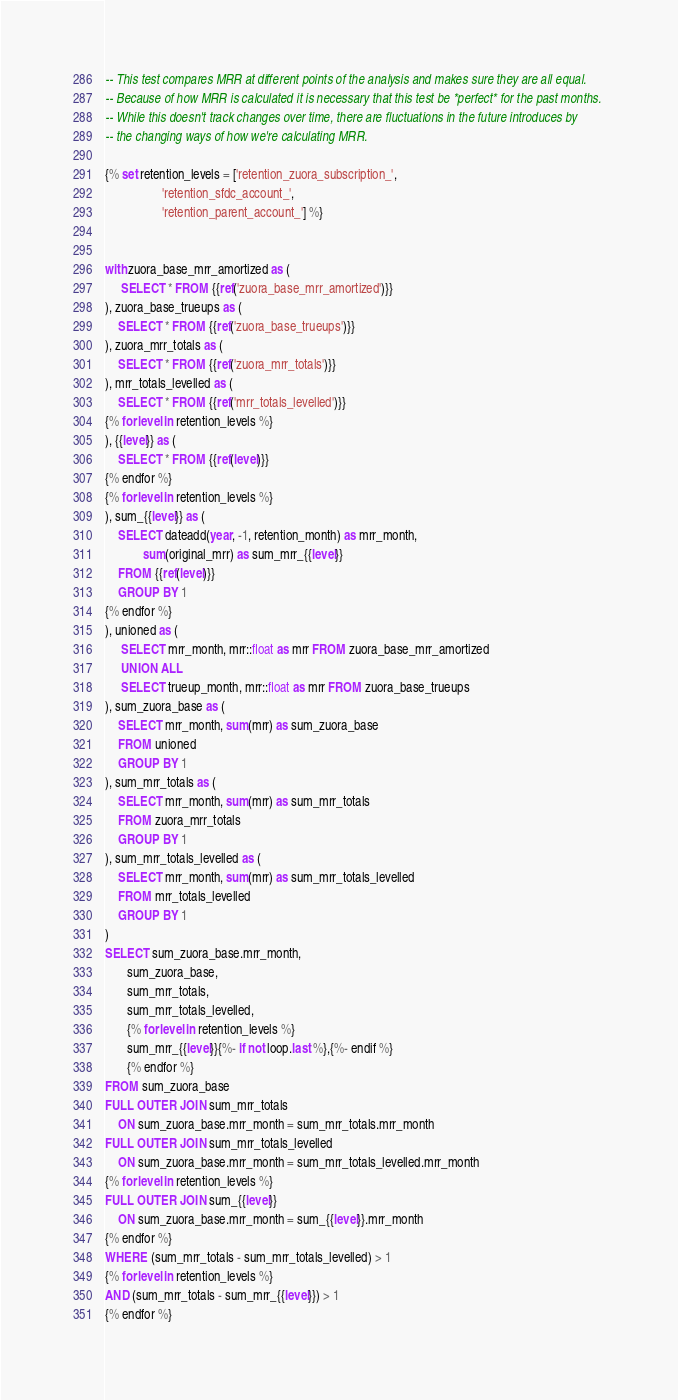Convert code to text. <code><loc_0><loc_0><loc_500><loc_500><_SQL_>-- This test compares MRR at different points of the analysis and makes sure they are all equal. 
-- Because of how MRR is calculated it is necessary that this test be *perfect* for the past months. 
-- While this doesn't track changes over time, there are fluctuations in the future introduces by 
-- the changing ways of how we're calculating MRR.

{% set retention_levels = ['retention_zuora_subscription_',
                  'retention_sfdc_account_',
                  'retention_parent_account_'] %}


with zuora_base_mrr_amortized as (
     SELECT * FROM {{ref('zuora_base_mrr_amortized')}}
), zuora_base_trueups as (
    SELECT * FROM {{ref('zuora_base_trueups')}}
), zuora_mrr_totals as (
    SELECT * FROM {{ref('zuora_mrr_totals')}}
), mrr_totals_levelled as (
    SELECT * FROM {{ref('mrr_totals_levelled')}}
{% for level in retention_levels %} 
), {{level}} as (
    SELECT * FROM {{ref(level)}}
{% endfor %} 
{% for level in retention_levels %} 
), sum_{{level}} as (
    SELECT dateadd(year, -1, retention_month) as mrr_month, 
            sum(original_mrr) as sum_mrr_{{level}}
    FROM {{ref(level)}}
    GROUP BY 1
{% endfor %} 
), unioned as (
     SELECT mrr_month, mrr::float as mrr FROM zuora_base_mrr_amortized
     UNION ALL
     SELECT trueup_month, mrr::float as mrr FROM zuora_base_trueups
), sum_zuora_base as (
    SELECT mrr_month, sum(mrr) as sum_zuora_base
    FROM unioned
    GROUP BY 1
), sum_mrr_totals as (
    SELECT mrr_month, sum(mrr) as sum_mrr_totals
    FROM zuora_mrr_totals
    GROUP BY 1
), sum_mrr_totals_levelled as (
    SELECT mrr_month, sum(mrr) as sum_mrr_totals_levelled
    FROM mrr_totals_levelled
    GROUP BY 1
)
SELECT sum_zuora_base.mrr_month,
       sum_zuora_base,
       sum_mrr_totals,
       sum_mrr_totals_levelled,
       {% for level in retention_levels %} 
       sum_mrr_{{level}}{%- if not loop.last %},{%- endif %}
       {% endfor %} 
FROM sum_zuora_base
FULL OUTER JOIN sum_mrr_totals
    ON sum_zuora_base.mrr_month = sum_mrr_totals.mrr_month
FULL OUTER JOIN sum_mrr_totals_levelled
    ON sum_zuora_base.mrr_month = sum_mrr_totals_levelled.mrr_month
{% for level in retention_levels %} 
FULL OUTER JOIN sum_{{level}}
    ON sum_zuora_base.mrr_month = sum_{{level}}.mrr_month
{% endfor %} 
WHERE (sum_mrr_totals - sum_mrr_totals_levelled) > 1
{% for level in retention_levels %} 
AND (sum_mrr_totals - sum_mrr_{{level}}) > 1
{% endfor %} 
</code> 